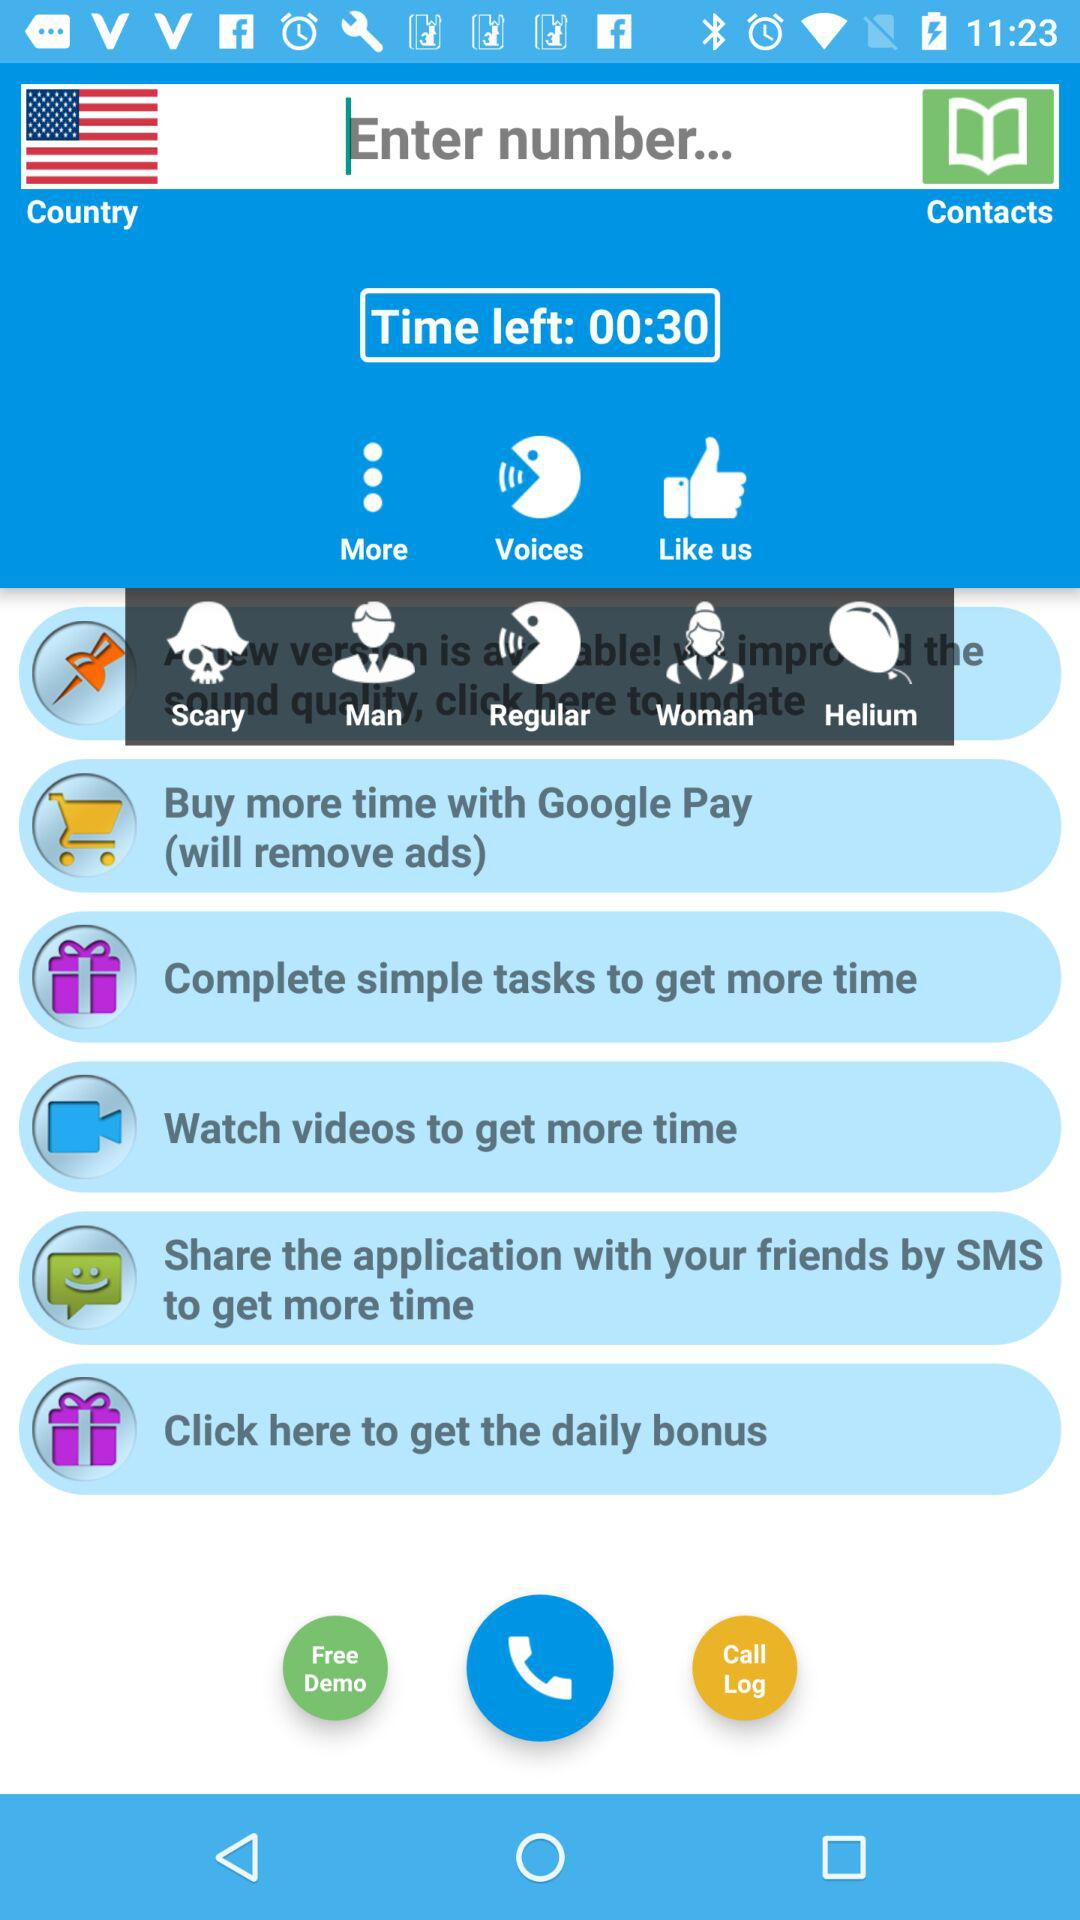How much time is left? Time left is 00:30. 